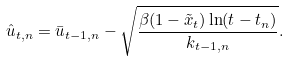Convert formula to latex. <formula><loc_0><loc_0><loc_500><loc_500>\hat { u } _ { t , n } = \bar { u } _ { t - 1 , n } - \sqrt { \frac { \beta ( 1 - \tilde { x } _ { t } ) \ln ( t - t _ { n } ) } { k _ { t - 1 , n } } } .</formula> 